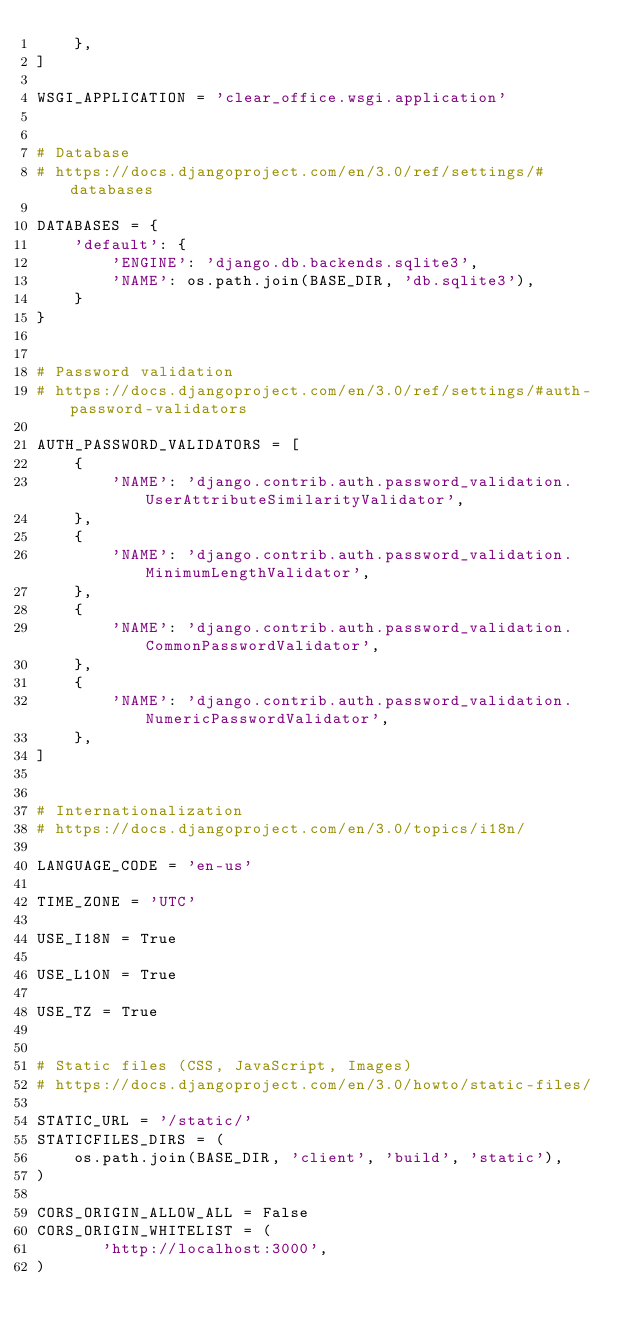Convert code to text. <code><loc_0><loc_0><loc_500><loc_500><_Python_>    },
]

WSGI_APPLICATION = 'clear_office.wsgi.application'


# Database
# https://docs.djangoproject.com/en/3.0/ref/settings/#databases

DATABASES = {
    'default': {
        'ENGINE': 'django.db.backends.sqlite3',
        'NAME': os.path.join(BASE_DIR, 'db.sqlite3'),
    }
}


# Password validation
# https://docs.djangoproject.com/en/3.0/ref/settings/#auth-password-validators

AUTH_PASSWORD_VALIDATORS = [
    {
        'NAME': 'django.contrib.auth.password_validation.UserAttributeSimilarityValidator',
    },
    {
        'NAME': 'django.contrib.auth.password_validation.MinimumLengthValidator',
    },
    {
        'NAME': 'django.contrib.auth.password_validation.CommonPasswordValidator',
    },
    {
        'NAME': 'django.contrib.auth.password_validation.NumericPasswordValidator',
    },
]


# Internationalization
# https://docs.djangoproject.com/en/3.0/topics/i18n/

LANGUAGE_CODE = 'en-us'

TIME_ZONE = 'UTC'

USE_I18N = True

USE_L10N = True

USE_TZ = True


# Static files (CSS, JavaScript, Images)
# https://docs.djangoproject.com/en/3.0/howto/static-files/

STATIC_URL = '/static/'
STATICFILES_DIRS = (
    os.path.join(BASE_DIR, 'client', 'build', 'static'),
)

CORS_ORIGIN_ALLOW_ALL = False
CORS_ORIGIN_WHITELIST = (
       'http://localhost:3000',
)</code> 